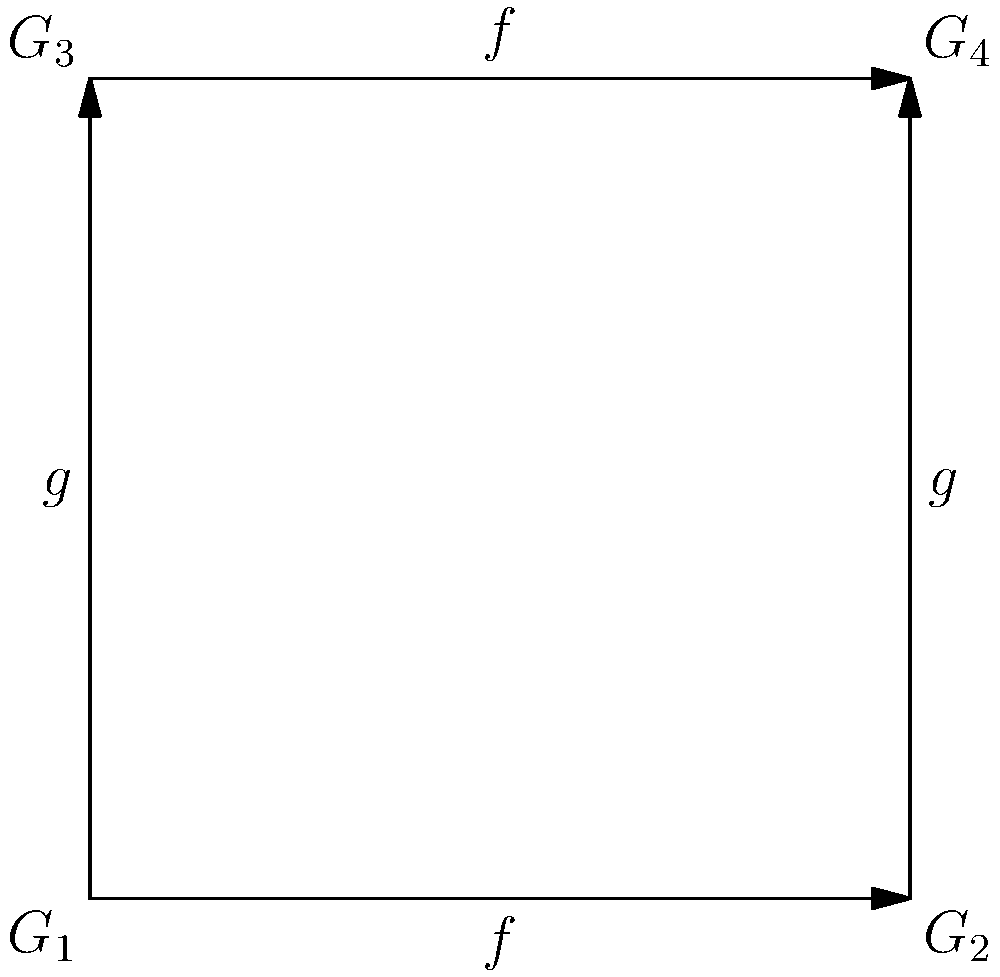Consider the directed graph representing a group homomorphism between groups $G_1$, $G_2$, $G_3$, and $G_4$. The arrows represent two functions $f$ and $g$. Which of the following statements must be true for this to represent a valid group homomorphism? 

a) $f \circ g = g \circ f$
b) $f(g(x)) = g(f(x))$ for all $x \in G_1$
c) $f(G_1) = G_2$ and $g(G_1) = G_3$
d) $f(G_3) = G_4$ and $g(G_2) = G_4$ To determine if this graph represents a valid group homomorphism, we need to check if the diagram commutes. This means that the composition of functions should yield the same result regardless of the path taken.

1) First, observe that there are two paths from $G_1$ to $G_4$:
   Path 1: $G_1 \xrightarrow{f} G_2 \xrightarrow{g} G_4$
   Path 2: $G_1 \xrightarrow{g} G_3 \xrightarrow{f} G_4$

2) For this to be a valid group homomorphism, these paths must yield the same result. Mathematically, this is expressed as:

   $f(g(x)) = g(f(x))$ for all $x \in G_1$

3) This condition is exactly what's stated in option b.

4) Option a ($f \circ g = g \circ f$) is a more general statement of commutativity, which is not necessarily true for all elements in the domain of $f$ and $g$.

5) Options c and d make statements about the images of the functions, which are not necessarily true for homomorphisms in general.

Therefore, the correct statement that must be true for this to represent a valid group homomorphism is option b.
Answer: b) $f(g(x)) = g(f(x))$ for all $x \in G_1$ 